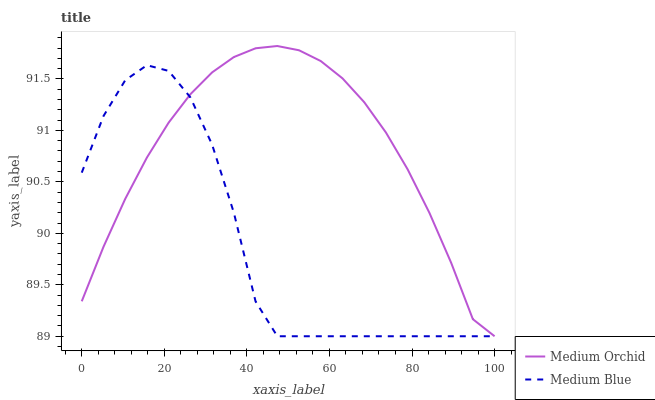Does Medium Blue have the minimum area under the curve?
Answer yes or no. Yes. Does Medium Orchid have the maximum area under the curve?
Answer yes or no. Yes. Does Medium Blue have the maximum area under the curve?
Answer yes or no. No. Is Medium Orchid the smoothest?
Answer yes or no. Yes. Is Medium Blue the roughest?
Answer yes or no. Yes. Is Medium Blue the smoothest?
Answer yes or no. No. Does Medium Orchid have the lowest value?
Answer yes or no. Yes. Does Medium Orchid have the highest value?
Answer yes or no. Yes. Does Medium Blue have the highest value?
Answer yes or no. No. Does Medium Orchid intersect Medium Blue?
Answer yes or no. Yes. Is Medium Orchid less than Medium Blue?
Answer yes or no. No. Is Medium Orchid greater than Medium Blue?
Answer yes or no. No. 